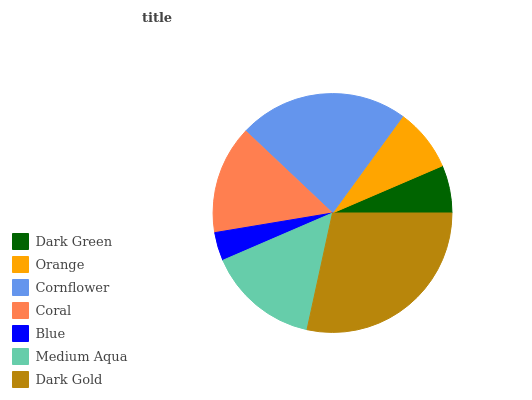Is Blue the minimum?
Answer yes or no. Yes. Is Dark Gold the maximum?
Answer yes or no. Yes. Is Orange the minimum?
Answer yes or no. No. Is Orange the maximum?
Answer yes or no. No. Is Orange greater than Dark Green?
Answer yes or no. Yes. Is Dark Green less than Orange?
Answer yes or no. Yes. Is Dark Green greater than Orange?
Answer yes or no. No. Is Orange less than Dark Green?
Answer yes or no. No. Is Coral the high median?
Answer yes or no. Yes. Is Coral the low median?
Answer yes or no. Yes. Is Dark Green the high median?
Answer yes or no. No. Is Dark Gold the low median?
Answer yes or no. No. 